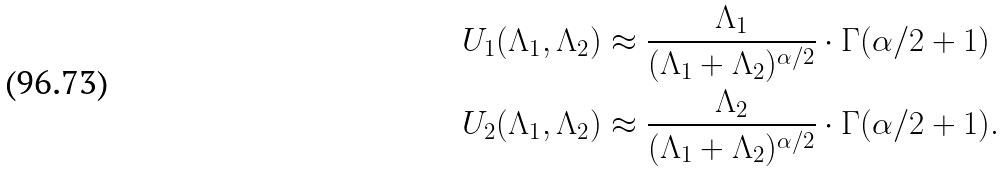<formula> <loc_0><loc_0><loc_500><loc_500>U _ { 1 } ( \Lambda _ { 1 } , \Lambda _ { 2 } ) & \approx \frac { \Lambda _ { 1 } } { ( \Lambda _ { 1 } + \Lambda _ { 2 } ) ^ { \alpha / 2 } } \cdot \Gamma ( \alpha / 2 + 1 ) \\ U _ { 2 } ( \Lambda _ { 1 } , \Lambda _ { 2 } ) & \approx \frac { \Lambda _ { 2 } } { ( \Lambda _ { 1 } + \Lambda _ { 2 } ) ^ { \alpha / 2 } } \cdot \Gamma ( \alpha / 2 + 1 ) .</formula> 